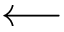Convert formula to latex. <formula><loc_0><loc_0><loc_500><loc_500>\longleftarrow</formula> 